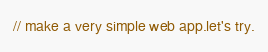Convert code to text. <code><loc_0><loc_0><loc_500><loc_500><_JavaScript_>// make a very simple web app.let's try.
</code> 